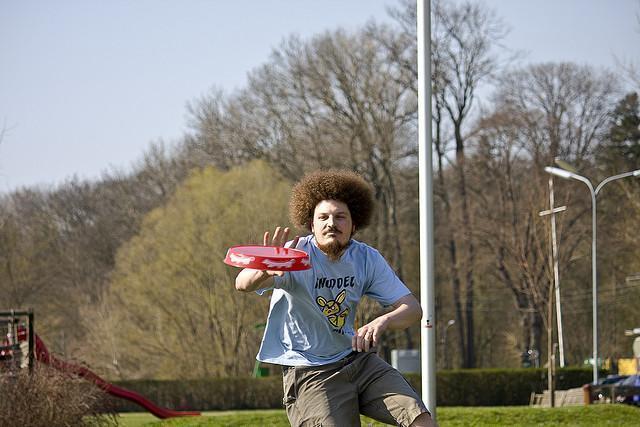What can be played on here?
Indicate the correct response by choosing from the four available options to answer the question.
Options: Trampoline, sand box, bounce castle, slide. Slide. 